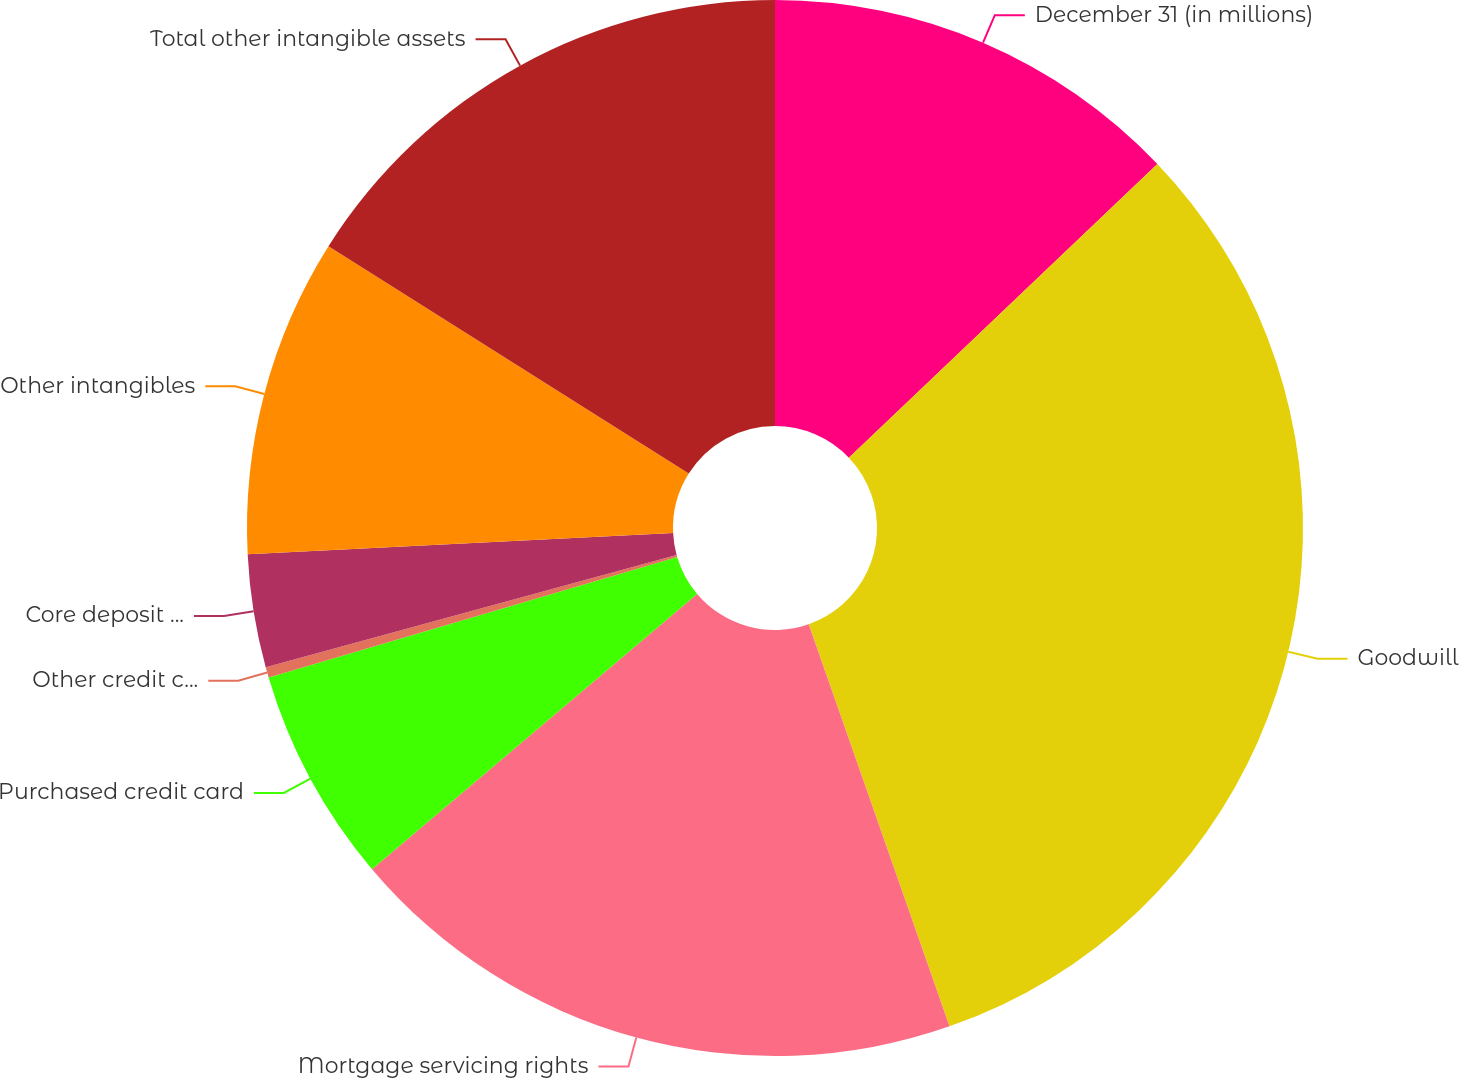<chart> <loc_0><loc_0><loc_500><loc_500><pie_chart><fcel>December 31 (in millions)<fcel>Goodwill<fcel>Mortgage servicing rights<fcel>Purchased credit card<fcel>Other credit card-related<fcel>Core deposit intangibles<fcel>Other intangibles<fcel>Total other intangible assets<nl><fcel>12.89%<fcel>31.75%<fcel>19.18%<fcel>6.61%<fcel>0.32%<fcel>3.46%<fcel>9.75%<fcel>16.04%<nl></chart> 